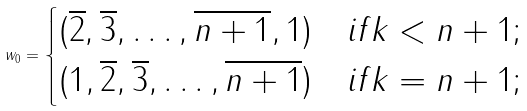Convert formula to latex. <formula><loc_0><loc_0><loc_500><loc_500>w _ { 0 } = \begin{cases} ( \overline { 2 } , \overline { 3 } , \dots , \overline { n + 1 } , 1 ) & i f k < n + 1 \/ ; \\ ( 1 , \overline { 2 } , \overline { 3 } , \dots , \overline { n + 1 } ) & i f k = n + 1 \/ ; \end{cases}</formula> 